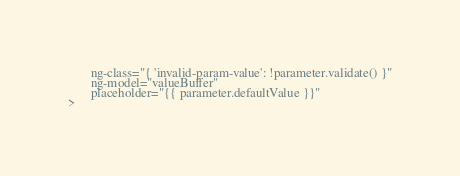<code> <loc_0><loc_0><loc_500><loc_500><_HTML_>       ng-class="{ 'invalid-param-value': !parameter.validate() }"
       ng-model="valueBuffer"
       placeholder="{{ parameter.defaultValue }}"
>

</code> 